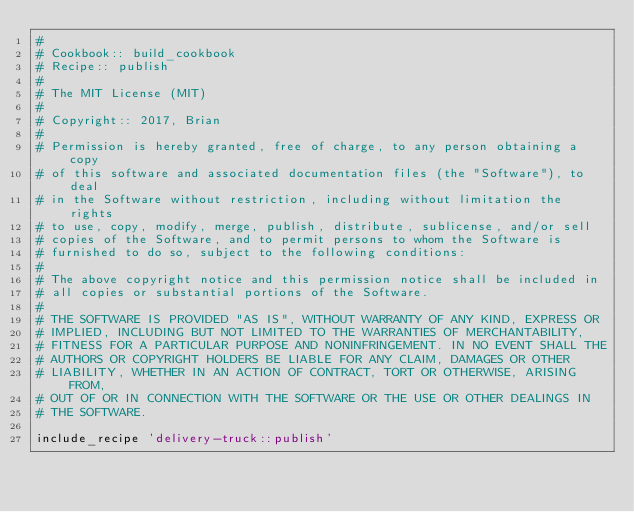<code> <loc_0><loc_0><loc_500><loc_500><_Ruby_>#
# Cookbook:: build_cookbook
# Recipe:: publish
#
# The MIT License (MIT)
#
# Copyright:: 2017, Brian
#
# Permission is hereby granted, free of charge, to any person obtaining a copy
# of this software and associated documentation files (the "Software"), to deal
# in the Software without restriction, including without limitation the rights
# to use, copy, modify, merge, publish, distribute, sublicense, and/or sell
# copies of the Software, and to permit persons to whom the Software is
# furnished to do so, subject to the following conditions:
#
# The above copyright notice and this permission notice shall be included in
# all copies or substantial portions of the Software.
#
# THE SOFTWARE IS PROVIDED "AS IS", WITHOUT WARRANTY OF ANY KIND, EXPRESS OR
# IMPLIED, INCLUDING BUT NOT LIMITED TO THE WARRANTIES OF MERCHANTABILITY,
# FITNESS FOR A PARTICULAR PURPOSE AND NONINFRINGEMENT. IN NO EVENT SHALL THE
# AUTHORS OR COPYRIGHT HOLDERS BE LIABLE FOR ANY CLAIM, DAMAGES OR OTHER
# LIABILITY, WHETHER IN AN ACTION OF CONTRACT, TORT OR OTHERWISE, ARISING FROM,
# OUT OF OR IN CONNECTION WITH THE SOFTWARE OR THE USE OR OTHER DEALINGS IN
# THE SOFTWARE.

include_recipe 'delivery-truck::publish'
</code> 